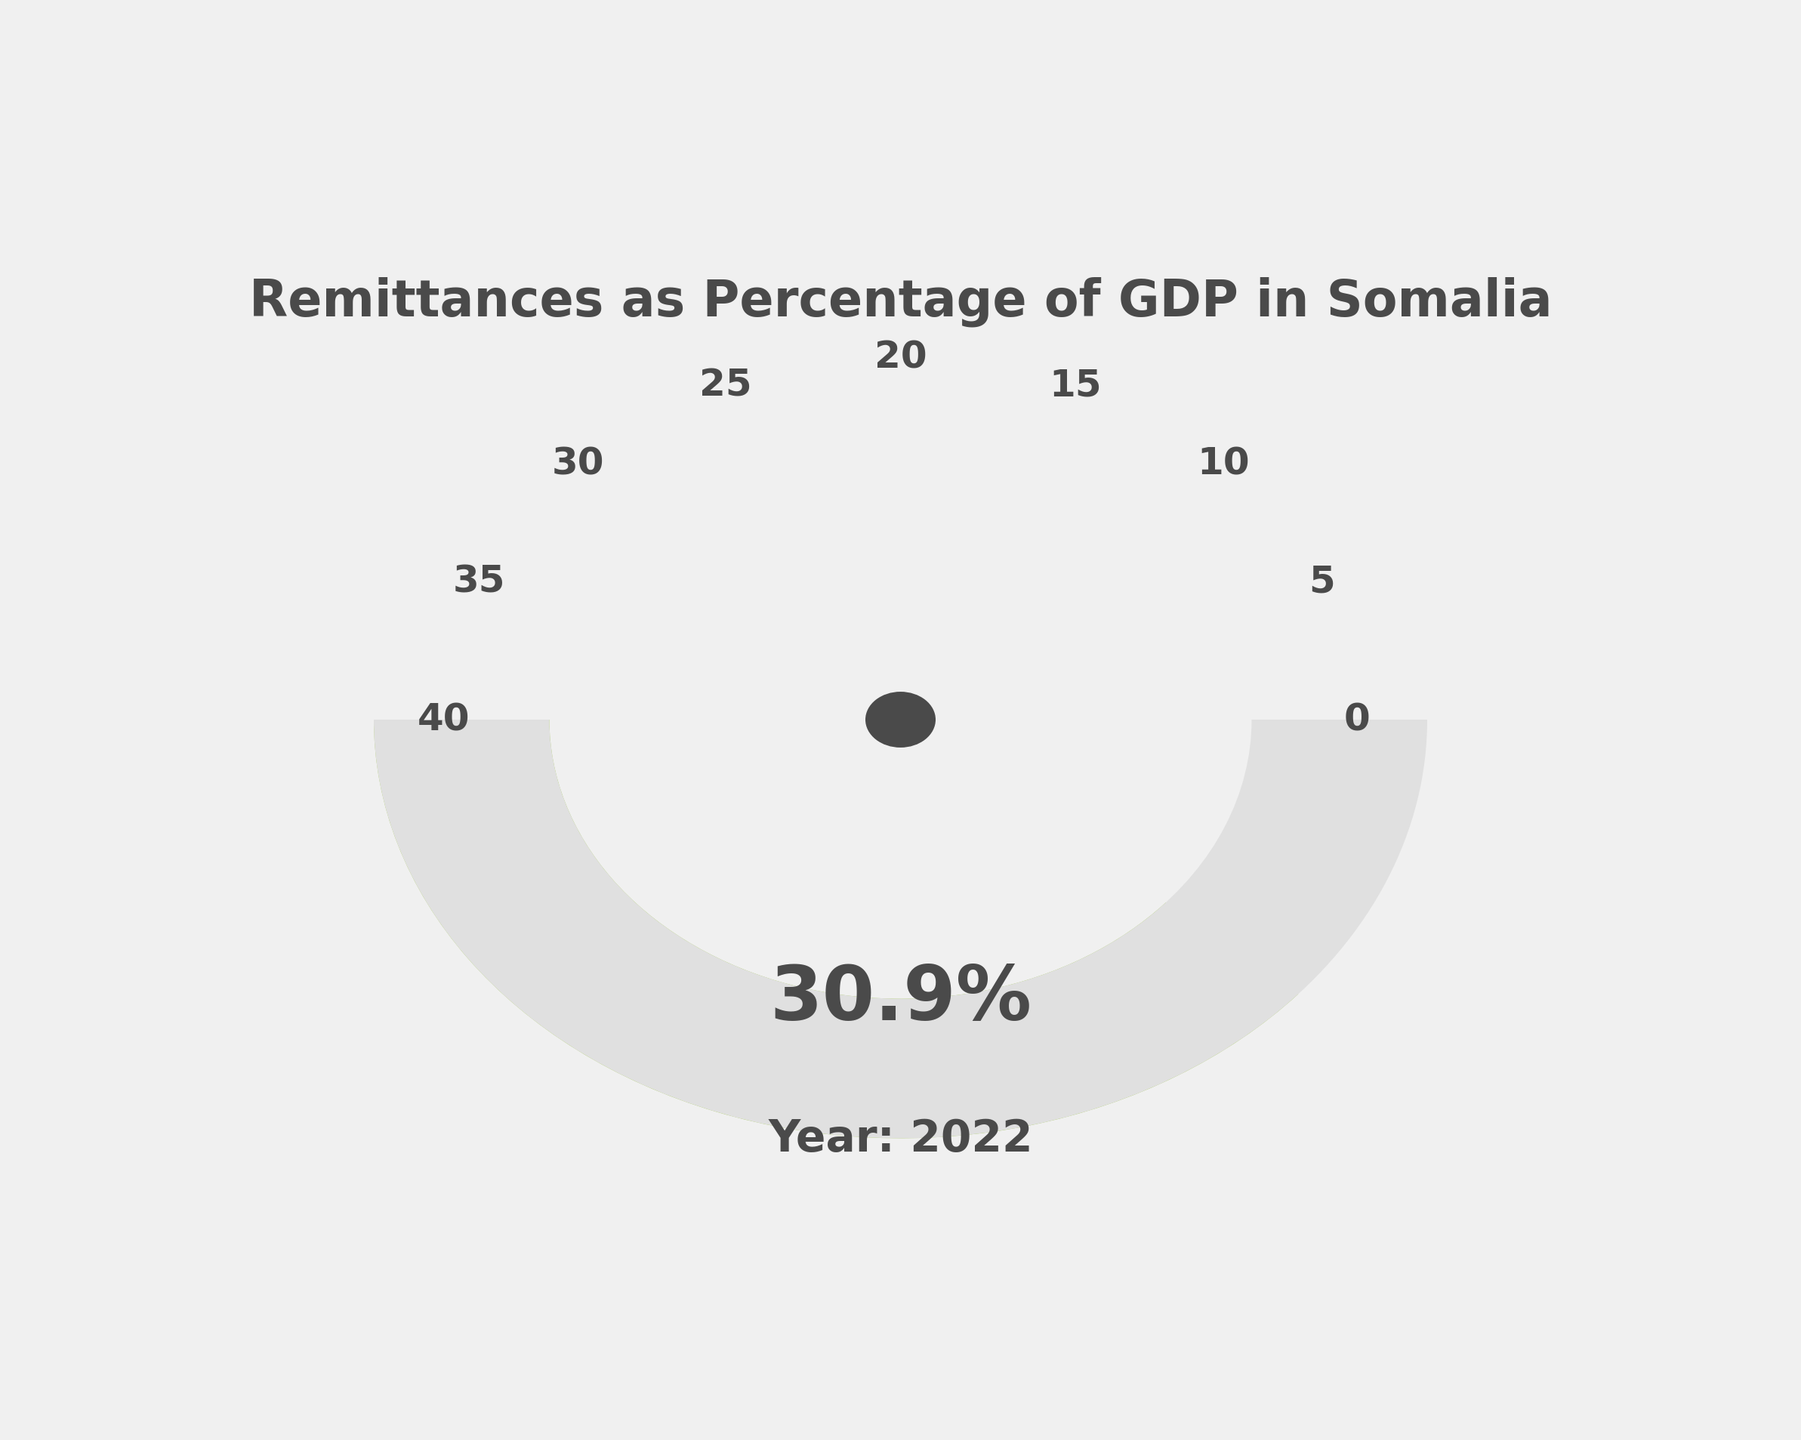What is the title of the gauge chart? The title of the chart is displayed prominently above the gauge, helping to understand the context of the figure. The title states what the chart is about.
Answer: Remittances as Percentage of GDP in Somalia What is the percentage of GDP contributed by remittances in the year 2022? The gauge shows the percentage value prominently in the chart. It is the key information that the chart conveys.
Answer: 30.9% How does the percentage of remittances to GDP in 2022 compare to the previous four years? By observing the data points and the segments of the gauge, we can compare the current year's value to previous years to see if it is higher or lower.
Answer: Lower than 2018, 2019, 2020, and 2021 What is the range of values displayed on the gauge? The gauge has tick marks at certain intervals. By checking these tick marks, one can identify the minimum and maximum range values.
Answer: 0 to 40 What is the average percentage of GDP contributed by remittances from 2018 to 2022? To find the average, add the percentages from 2018 to 2022 and divide by 5. The values are 31.4, 32.1, 35.3, 33.8, and 30.9.
Answer: (31.4 + 32.1 + 35.3 + 33.8 + 30.9) / 5 = 32.7% Which year had the highest percentage of GDP from remittances? Reviewing the data values over the years, the highest percentage value can be identified easily.
Answer: 2020 What color is the segment of the gauge that represents the current year's remittances percentage? The segment color shows the represented value. The gauge uses a color gradient, so the current year’s value will correspond with a specific color on the gauge.
Answer: A shade between yellow and green Which percentage value is closest to the center of the gauge? By examining closely where the needle or the segment ends, the closest tick value to the needle is the answer. Ticks are denoted in intervals on the gauge.
Answer: 30 By how much did the percentage of GDP contributed by remittances decrease from 2021 to 2022? Subtract the remittances percentage of 2022 from that of 2021. 2021 value is 33.8% and 2022 value is 30.9%.
Answer: 33.8 - 30.9 = 2.9% What can be inferred from the position of the gauge in terms of the economic contribution of remittances relative to the set limits? The gauge shows the economic contribution value on a scale. Discussing its position relative to these edges provides insight into its economic significance.
Answer: The remittances contribute substantially to GDP, being closer to the higher end of the scale 